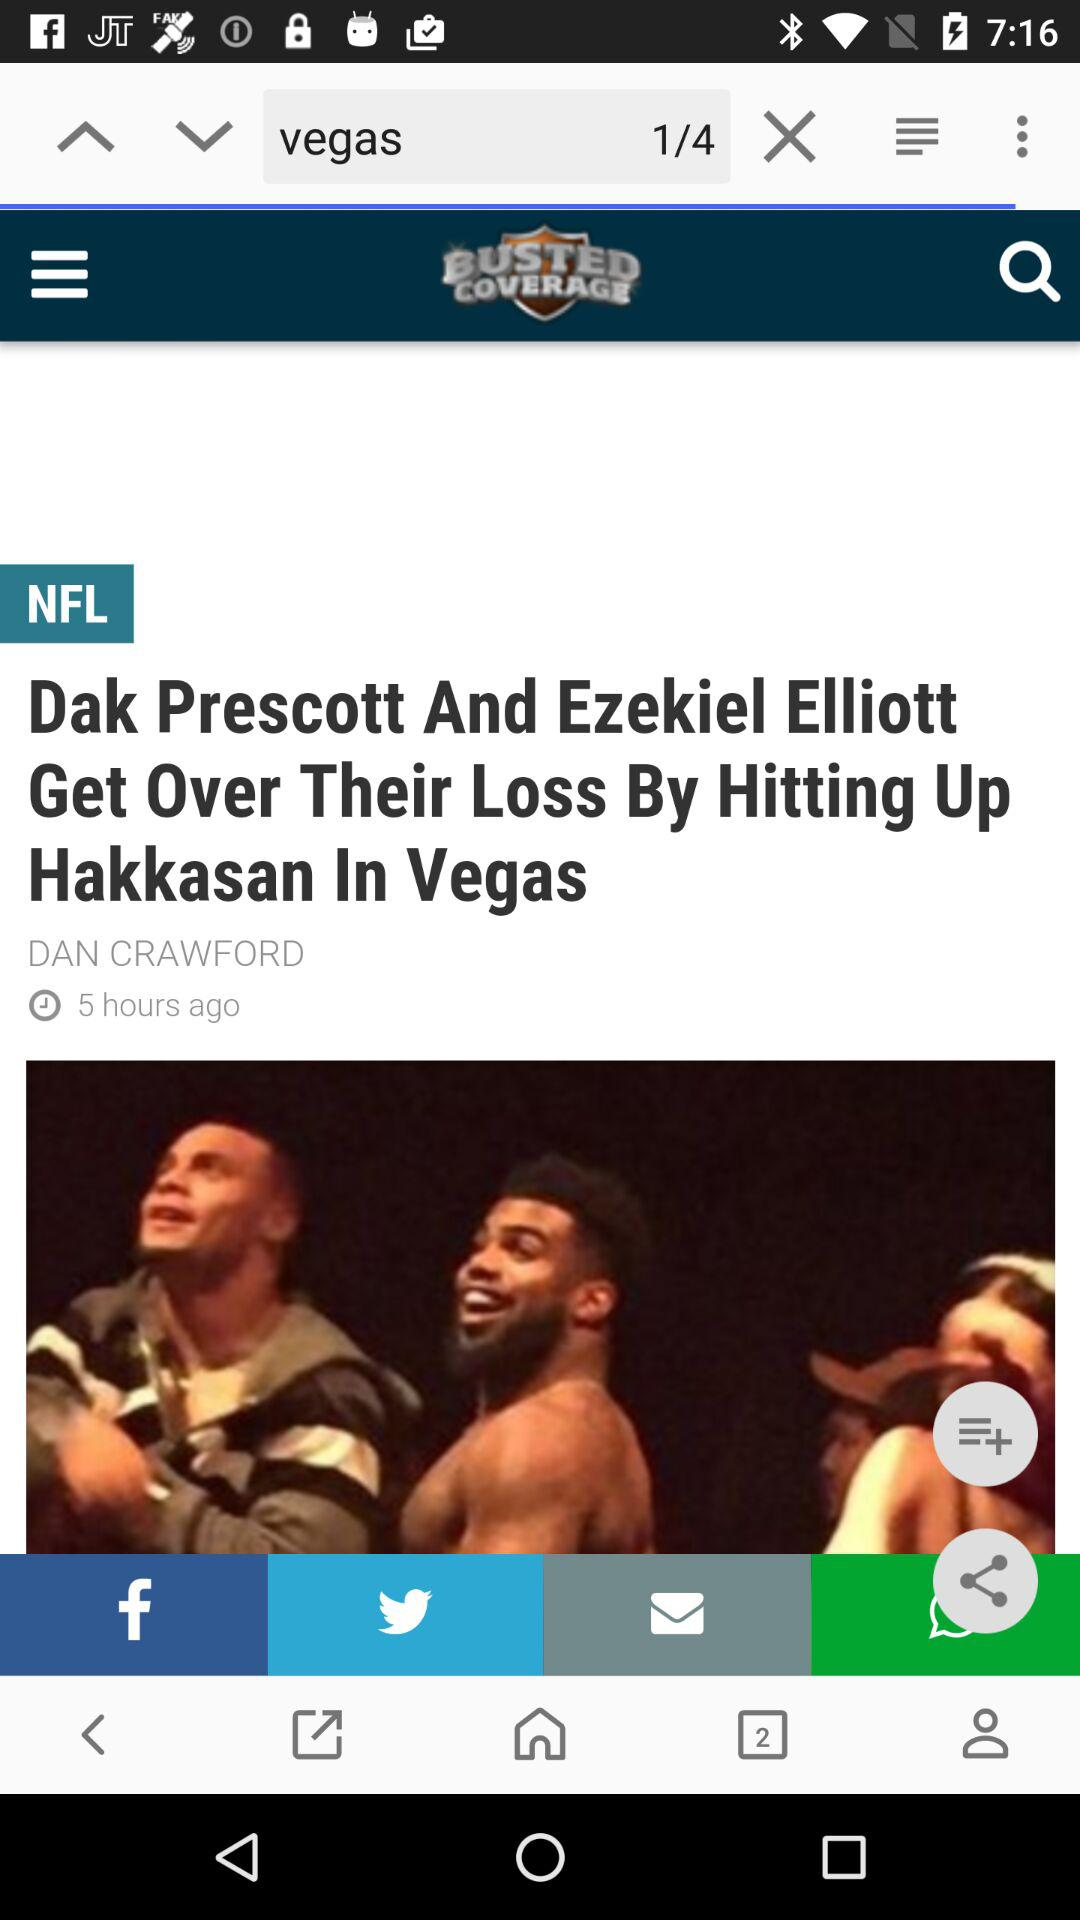What is the title of the article? The title of the article is "Dak Prescott And Ezekiel Elliott Get Over Their Loss By Hitting Up Hakkasan In Vegas". 